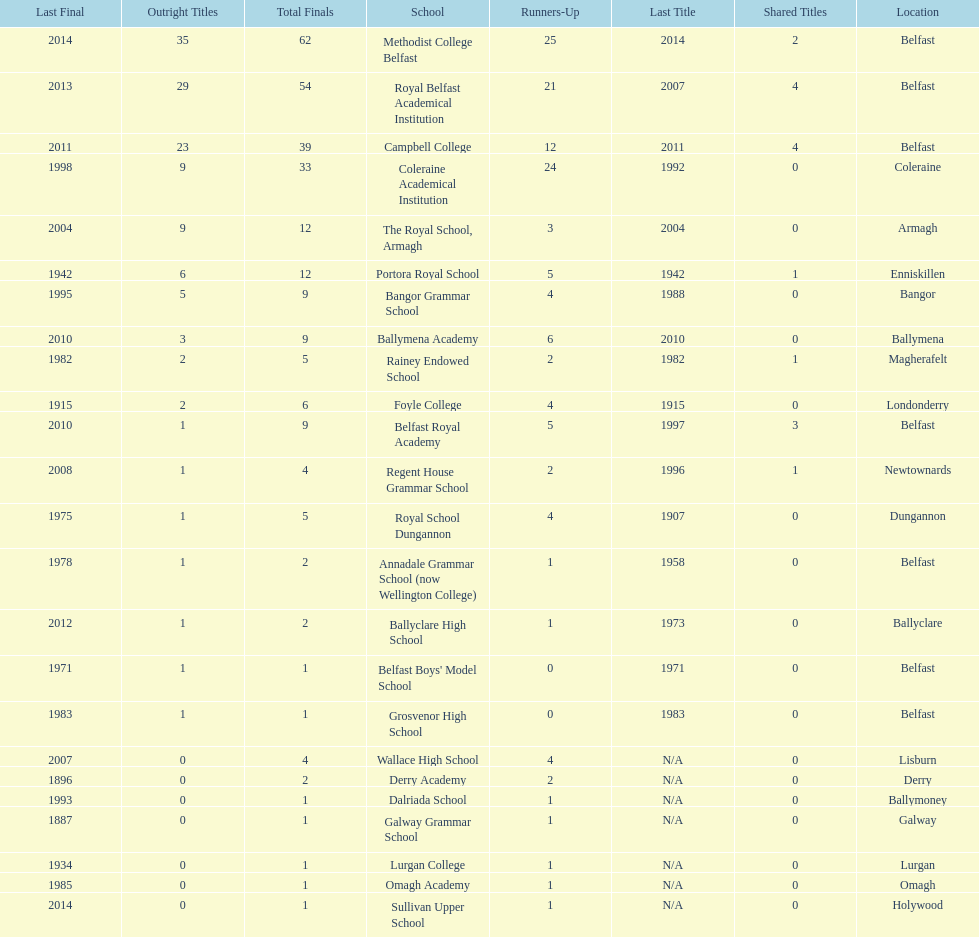Which two schools each had twelve total finals? The Royal School, Armagh, Portora Royal School. Would you mind parsing the complete table? {'header': ['Last Final', 'Outright Titles', 'Total Finals', 'School', 'Runners-Up', 'Last Title', 'Shared Titles', 'Location'], 'rows': [['2014', '35', '62', 'Methodist College Belfast', '25', '2014', '2', 'Belfast'], ['2013', '29', '54', 'Royal Belfast Academical Institution', '21', '2007', '4', 'Belfast'], ['2011', '23', '39', 'Campbell College', '12', '2011', '4', 'Belfast'], ['1998', '9', '33', 'Coleraine Academical Institution', '24', '1992', '0', 'Coleraine'], ['2004', '9', '12', 'The Royal School, Armagh', '3', '2004', '0', 'Armagh'], ['1942', '6', '12', 'Portora Royal School', '5', '1942', '1', 'Enniskillen'], ['1995', '5', '9', 'Bangor Grammar School', '4', '1988', '0', 'Bangor'], ['2010', '3', '9', 'Ballymena Academy', '6', '2010', '0', 'Ballymena'], ['1982', '2', '5', 'Rainey Endowed School', '2', '1982', '1', 'Magherafelt'], ['1915', '2', '6', 'Foyle College', '4', '1915', '0', 'Londonderry'], ['2010', '1', '9', 'Belfast Royal Academy', '5', '1997', '3', 'Belfast'], ['2008', '1', '4', 'Regent House Grammar School', '2', '1996', '1', 'Newtownards'], ['1975', '1', '5', 'Royal School Dungannon', '4', '1907', '0', 'Dungannon'], ['1978', '1', '2', 'Annadale Grammar School (now Wellington College)', '1', '1958', '0', 'Belfast'], ['2012', '1', '2', 'Ballyclare High School', '1', '1973', '0', 'Ballyclare'], ['1971', '1', '1', "Belfast Boys' Model School", '0', '1971', '0', 'Belfast'], ['1983', '1', '1', 'Grosvenor High School', '0', '1983', '0', 'Belfast'], ['2007', '0', '4', 'Wallace High School', '4', 'N/A', '0', 'Lisburn'], ['1896', '0', '2', 'Derry Academy', '2', 'N/A', '0', 'Derry'], ['1993', '0', '1', 'Dalriada School', '1', 'N/A', '0', 'Ballymoney'], ['1887', '0', '1', 'Galway Grammar School', '1', 'N/A', '0', 'Galway'], ['1934', '0', '1', 'Lurgan College', '1', 'N/A', '0', 'Lurgan'], ['1985', '0', '1', 'Omagh Academy', '1', 'N/A', '0', 'Omagh'], ['2014', '0', '1', 'Sullivan Upper School', '1', 'N/A', '0', 'Holywood']]} 